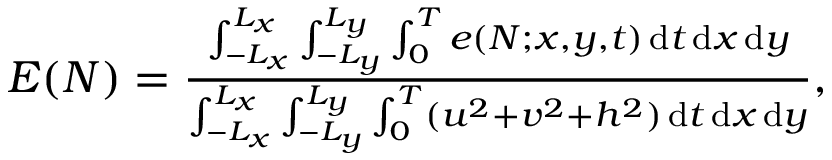Convert formula to latex. <formula><loc_0><loc_0><loc_500><loc_500>\begin{array} { r } { E ( N ) = \frac { \int _ { - L _ { x } } ^ { L _ { x } } \int _ { - L _ { y } } ^ { L _ { y } } \int _ { 0 } ^ { T } e ( N ; x , y , t ) \, d t \, d x \, d y } { \int _ { - L _ { x } } ^ { L _ { x } } \int _ { - L _ { y } } ^ { L _ { y } } \int _ { 0 } ^ { T } ( u ^ { 2 } + v ^ { 2 } + h ^ { 2 } ) \, d t \, d x \, d y } , } \end{array}</formula> 